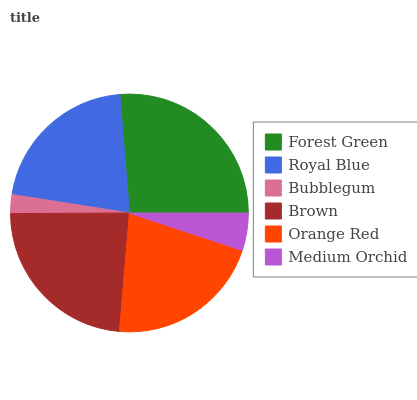Is Bubblegum the minimum?
Answer yes or no. Yes. Is Forest Green the maximum?
Answer yes or no. Yes. Is Royal Blue the minimum?
Answer yes or no. No. Is Royal Blue the maximum?
Answer yes or no. No. Is Forest Green greater than Royal Blue?
Answer yes or no. Yes. Is Royal Blue less than Forest Green?
Answer yes or no. Yes. Is Royal Blue greater than Forest Green?
Answer yes or no. No. Is Forest Green less than Royal Blue?
Answer yes or no. No. Is Orange Red the high median?
Answer yes or no. Yes. Is Royal Blue the low median?
Answer yes or no. Yes. Is Royal Blue the high median?
Answer yes or no. No. Is Orange Red the low median?
Answer yes or no. No. 